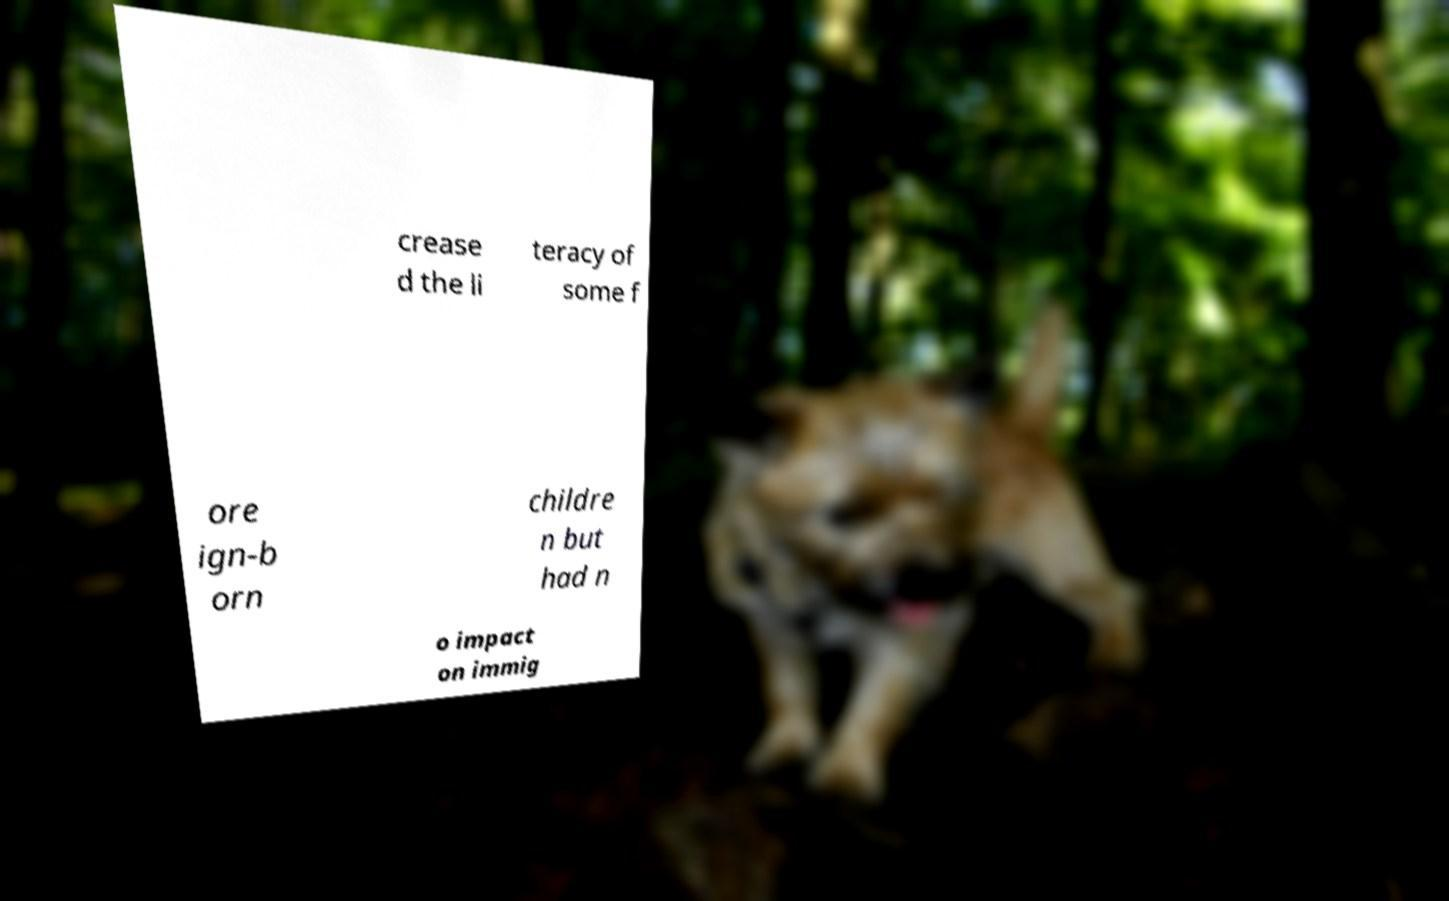Can you read and provide the text displayed in the image?This photo seems to have some interesting text. Can you extract and type it out for me? crease d the li teracy of some f ore ign-b orn childre n but had n o impact on immig 